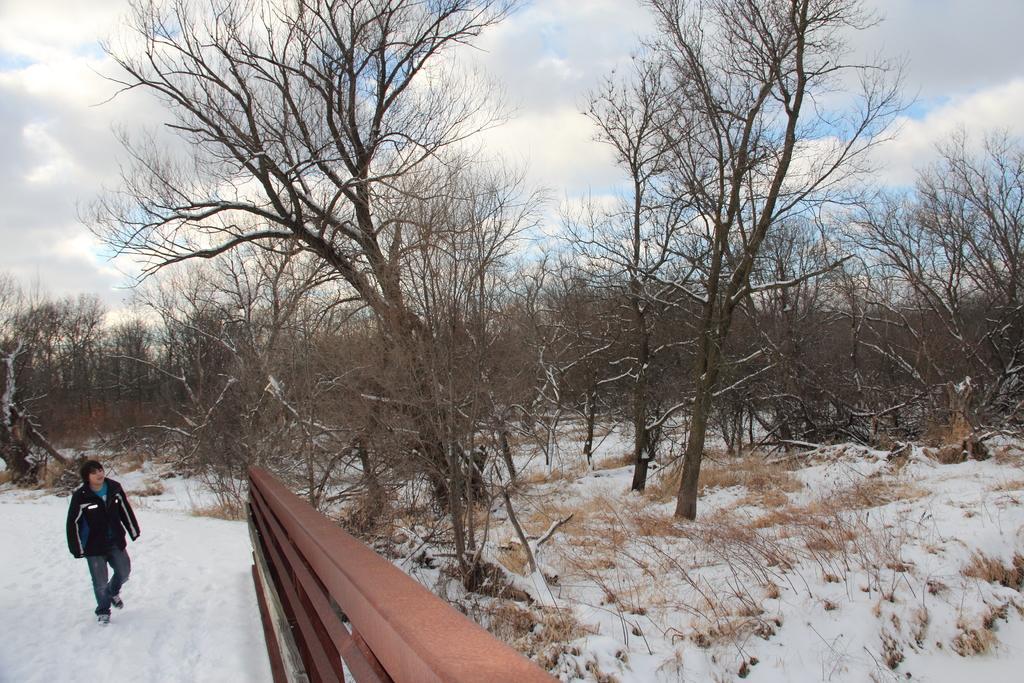In one or two sentences, can you explain what this image depicts? In this image there is one person standing in the bottom left side of this image and there is a wooden gate in the bottom of this image. There are some trees in the background. There is a sky on the top of this image. 